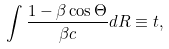Convert formula to latex. <formula><loc_0><loc_0><loc_500><loc_500>\int \frac { 1 - \beta \cos \Theta } { \beta c } d R \equiv t ,</formula> 